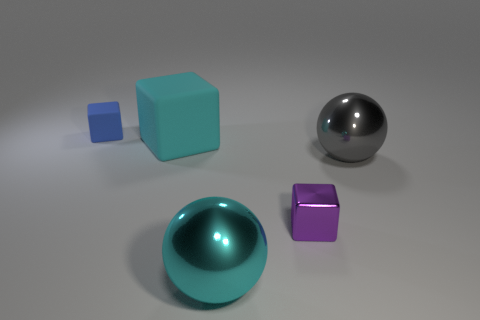Is the material of the cyan sphere the same as the small block in front of the gray metallic object?
Ensure brevity in your answer.  Yes. How many things are either cyan metal cubes or large matte cubes?
Provide a succinct answer. 1. There is a sphere behind the cyan metal object; does it have the same size as the rubber block behind the large cyan block?
Give a very brief answer. No. What number of spheres are either cyan matte things or blue rubber objects?
Ensure brevity in your answer.  0. Is there a purple ball?
Provide a short and direct response. No. Is there any other thing that has the same shape as the purple shiny object?
Provide a short and direct response. Yes. Does the tiny rubber thing have the same color as the small metal object?
Provide a short and direct response. No. What number of objects are either things behind the gray metallic object or big green shiny cubes?
Your response must be concise. 2. There is a small object in front of the object to the left of the large rubber block; how many large cyan matte blocks are to the right of it?
Offer a terse response. 0. Is there any other thing that is the same size as the blue rubber object?
Provide a succinct answer. Yes. 